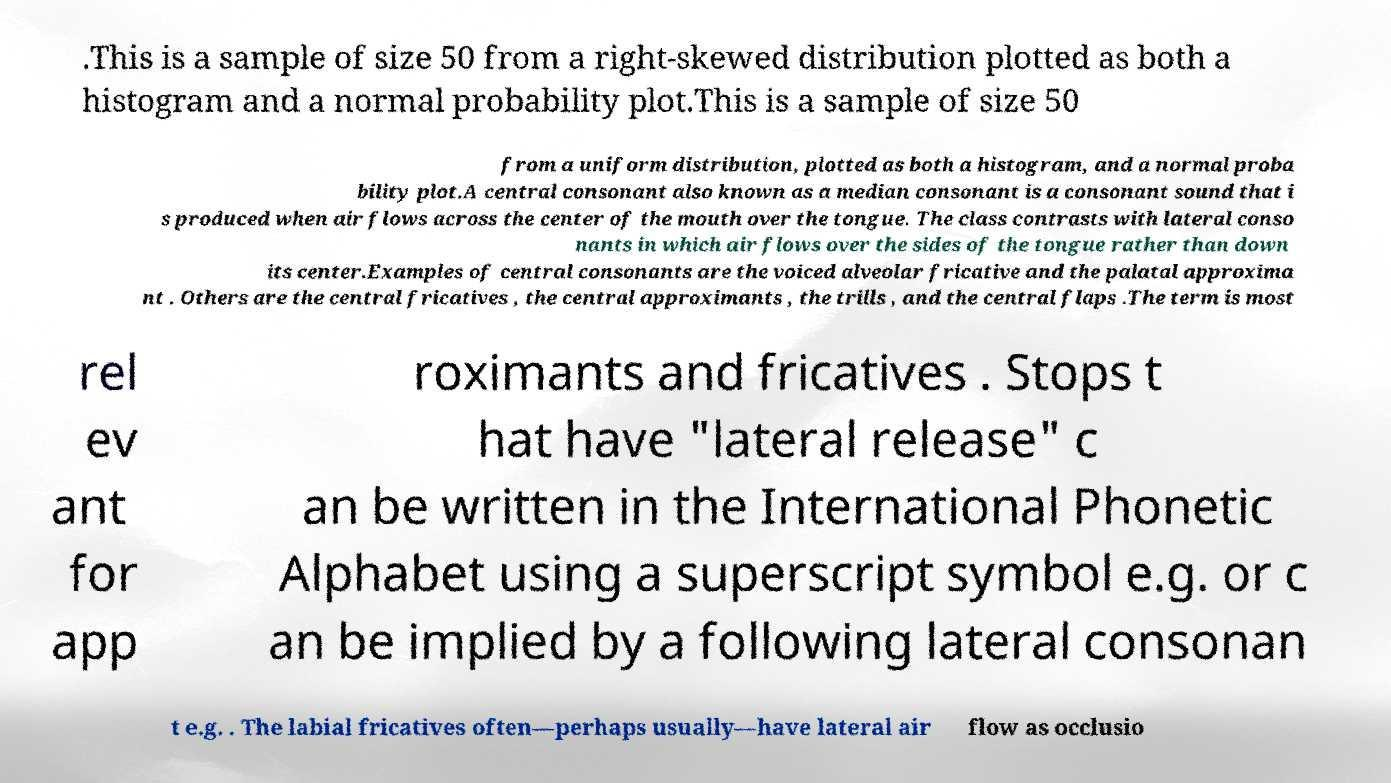Can you accurately transcribe the text from the provided image for me? .This is a sample of size 50 from a right-skewed distribution plotted as both a histogram and a normal probability plot.This is a sample of size 50 from a uniform distribution, plotted as both a histogram, and a normal proba bility plot.A central consonant also known as a median consonant is a consonant sound that i s produced when air flows across the center of the mouth over the tongue. The class contrasts with lateral conso nants in which air flows over the sides of the tongue rather than down its center.Examples of central consonants are the voiced alveolar fricative and the palatal approxima nt . Others are the central fricatives , the central approximants , the trills , and the central flaps .The term is most rel ev ant for app roximants and fricatives . Stops t hat have "lateral release" c an be written in the International Phonetic Alphabet using a superscript symbol e.g. or c an be implied by a following lateral consonan t e.g. . The labial fricatives often—perhaps usually—have lateral air flow as occlusio 